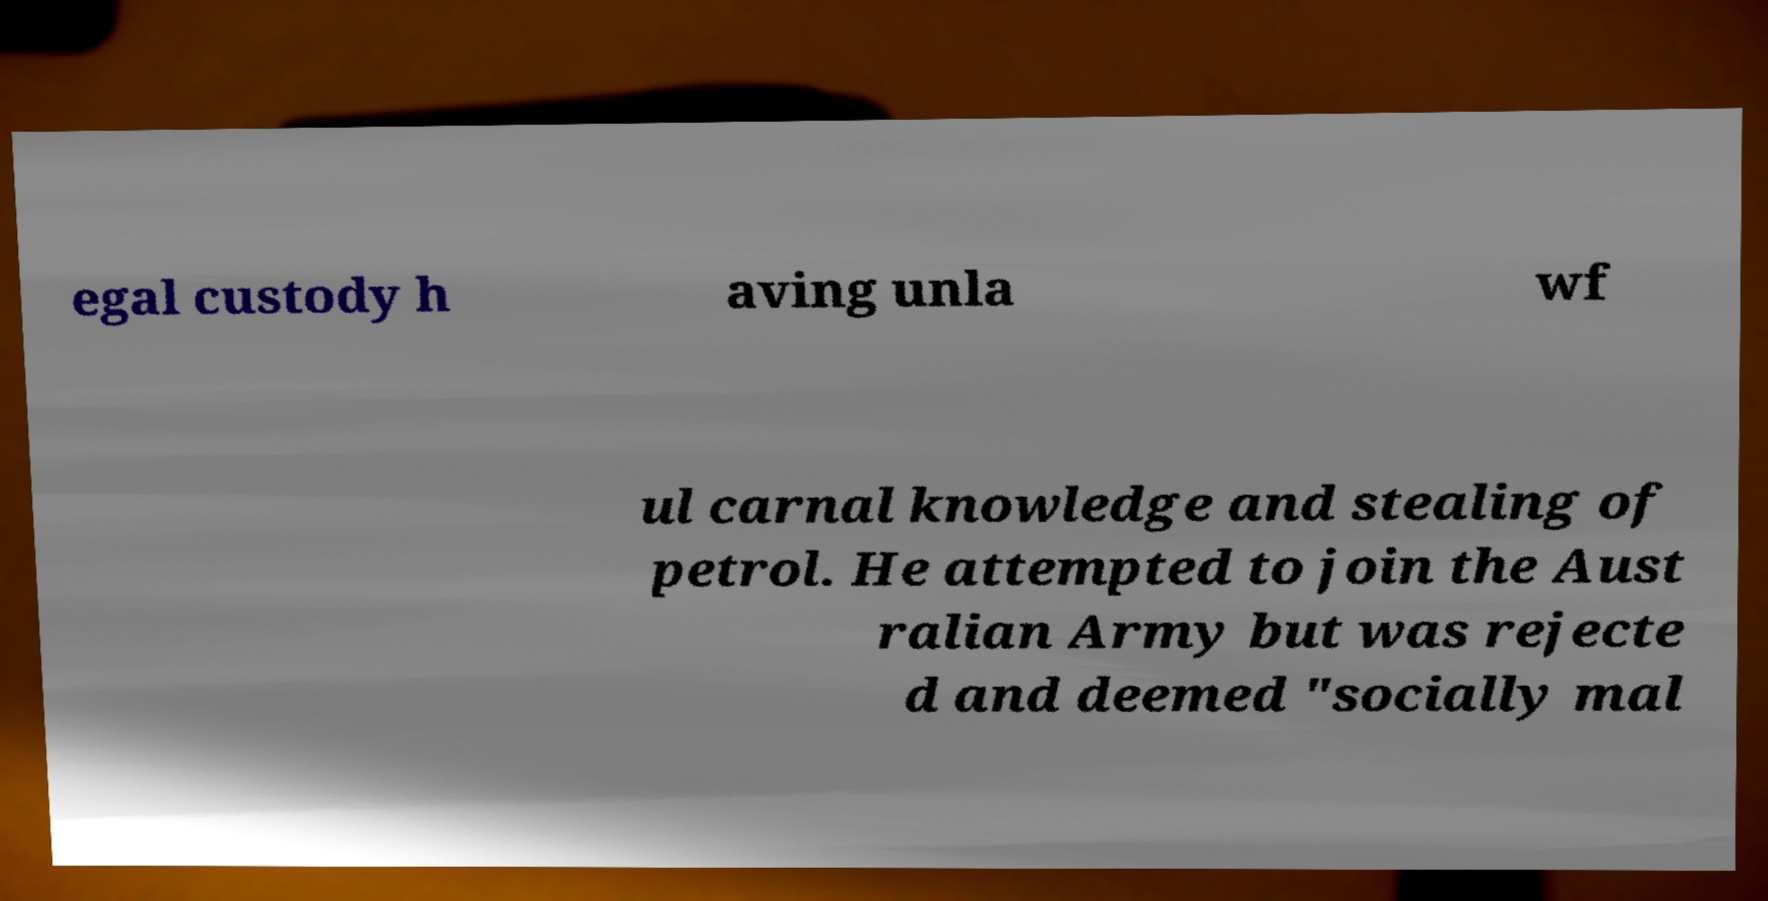Can you read and provide the text displayed in the image?This photo seems to have some interesting text. Can you extract and type it out for me? egal custody h aving unla wf ul carnal knowledge and stealing of petrol. He attempted to join the Aust ralian Army but was rejecte d and deemed "socially mal 